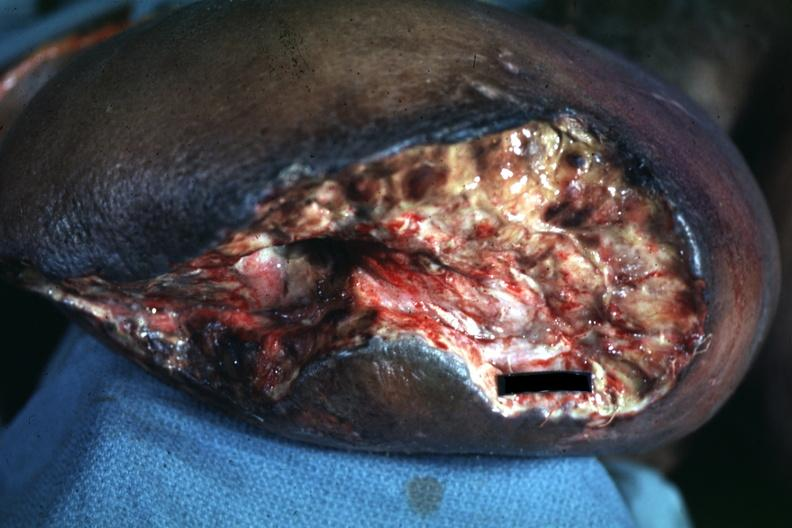does feet show open nasty looking wound appears to be mid thigh?
Answer the question using a single word or phrase. No 